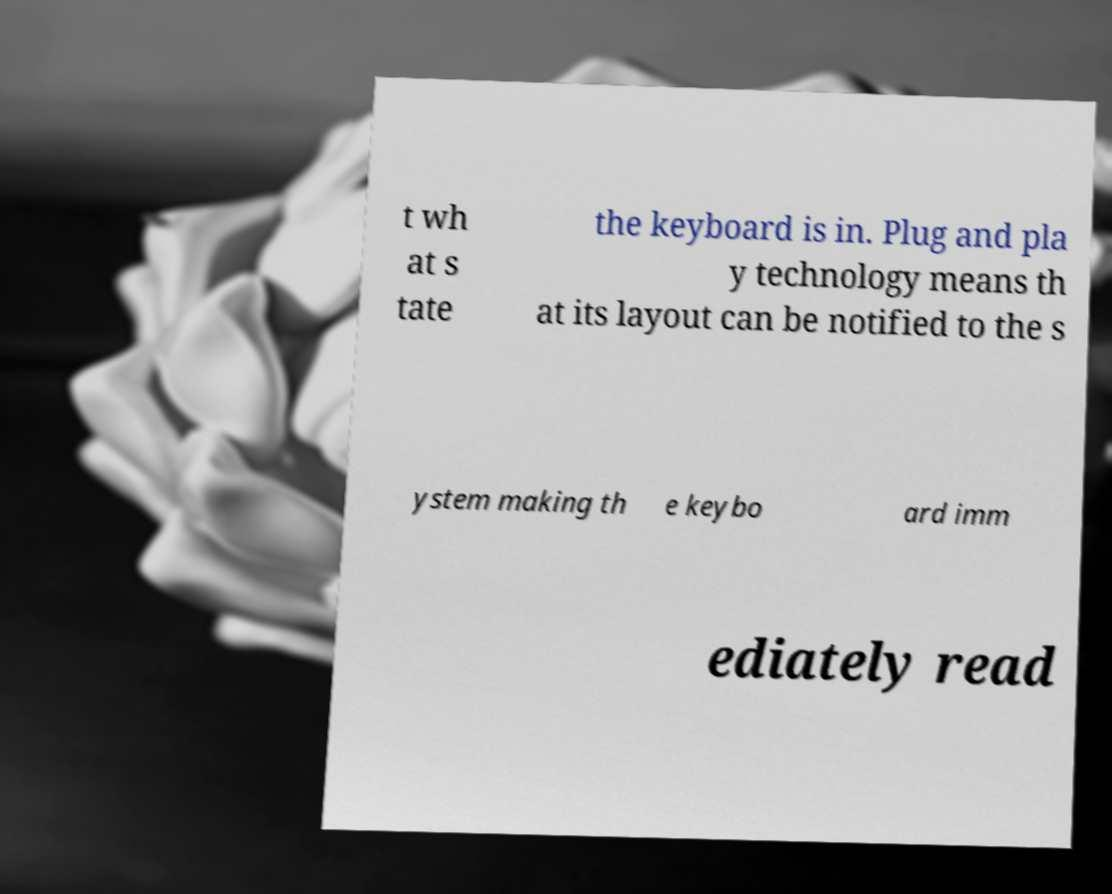Could you assist in decoding the text presented in this image and type it out clearly? t wh at s tate the keyboard is in. Plug and pla y technology means th at its layout can be notified to the s ystem making th e keybo ard imm ediately read 